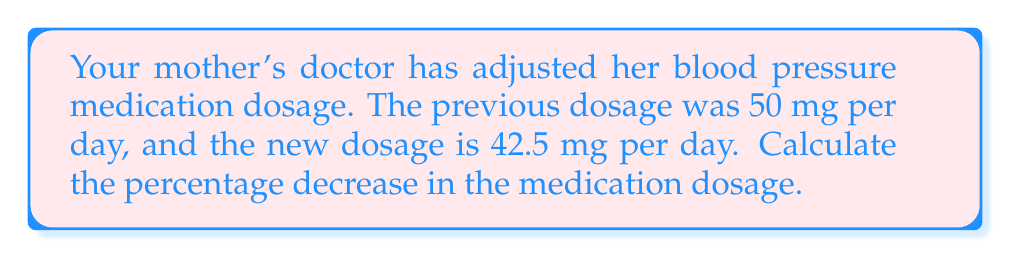Teach me how to tackle this problem. To calculate the percentage decrease, we'll follow these steps:

1. Calculate the difference between the old and new dosages:
   $50 \text{ mg} - 42.5 \text{ mg} = 7.5 \text{ mg}$

2. Divide the difference by the original dosage:
   $\frac{7.5 \text{ mg}}{50 \text{ mg}} = 0.15$

3. Convert the decimal to a percentage by multiplying by 100:
   $0.15 \times 100 = 15\%$

The formula for percentage decrease is:

$$ \text{Percentage Decrease} = \frac{\text{Original Value} - \text{New Value}}{\text{Original Value}} \times 100\% $$

Plugging in our values:

$$ \text{Percentage Decrease} = \frac{50 \text{ mg} - 42.5 \text{ mg}}{50 \text{ mg}} \times 100\% = \frac{7.5 \text{ mg}}{50 \text{ mg}} \times 100\% = 0.15 \times 100\% = 15\% $$

Therefore, the percentage decrease in the medication dosage is 15%.
Answer: 15% 